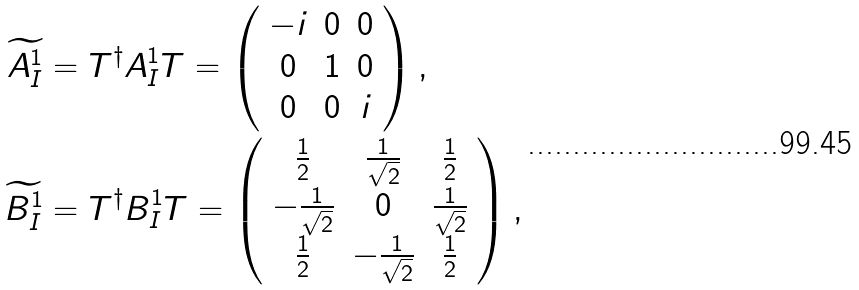<formula> <loc_0><loc_0><loc_500><loc_500>\widetilde { A _ { I } ^ { 1 } } & = T ^ { \dagger } A _ { I } ^ { 1 } T = \left ( \begin{array} { c c c } - i & 0 & 0 \\ 0 & 1 & 0 \\ 0 & 0 & i \end{array} \right ) , \\ \widetilde { B _ { I } ^ { 1 } } & = T ^ { \dagger } B _ { I } ^ { 1 } T = \left ( \begin{array} { c c c } \frac { 1 } { 2 } & \frac { 1 } { \sqrt { 2 } } & \frac { 1 } { 2 } \\ - \frac { 1 } { \sqrt { 2 } } & 0 & \frac { 1 } { \sqrt { 2 } } \\ \frac { 1 } { 2 } & - \frac { 1 } { \sqrt { 2 } } & \frac { 1 } { 2 } \end{array} \right ) ,</formula> 